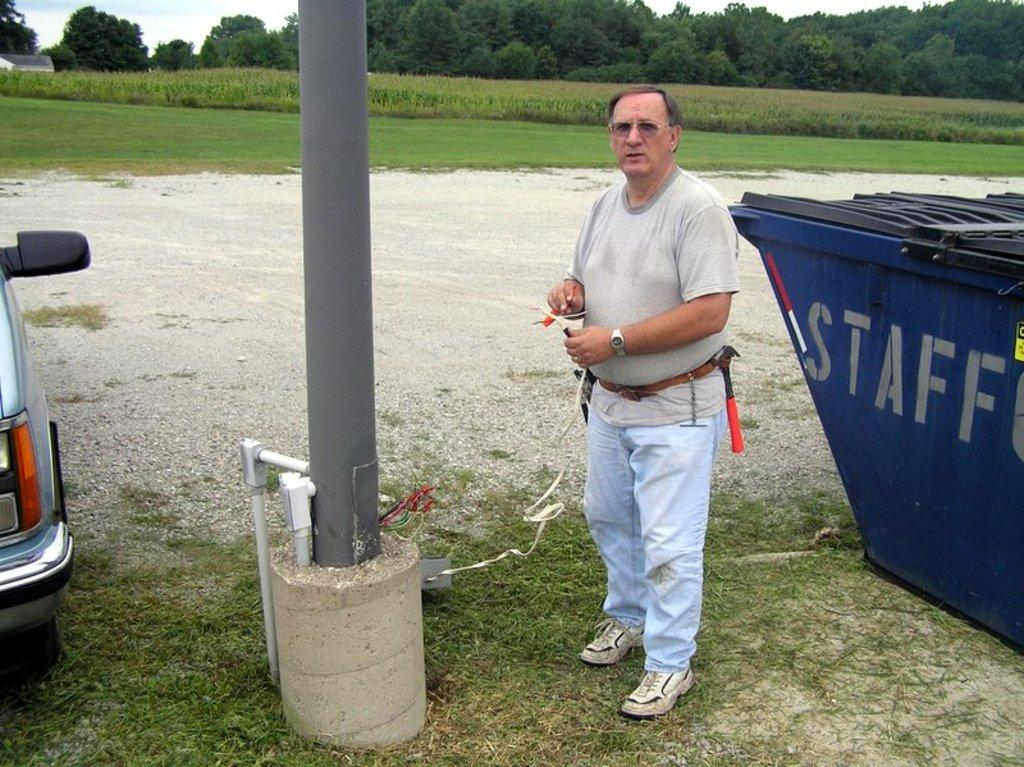<image>
Summarize the visual content of the image. A man works on a light pole near a large staff garbage bin. 